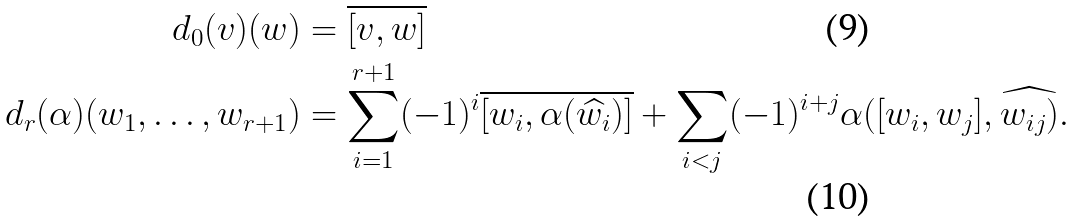Convert formula to latex. <formula><loc_0><loc_0><loc_500><loc_500>d _ { 0 } ( v ) ( w ) & = \overline { [ v , w ] } \\ d _ { r } ( \alpha ) ( w _ { 1 } , \dots , w _ { r + 1 } ) & = \sum _ { i = 1 } ^ { r + 1 } ( - 1 ) ^ { i } \overline { [ w _ { i } , \alpha ( \widehat { w _ { i } } ) ] } + \sum _ { i < j } ( - 1 ) ^ { i + j } \alpha ( [ w _ { i } , w _ { j } ] , \widehat { w _ { i j } ) } .</formula> 